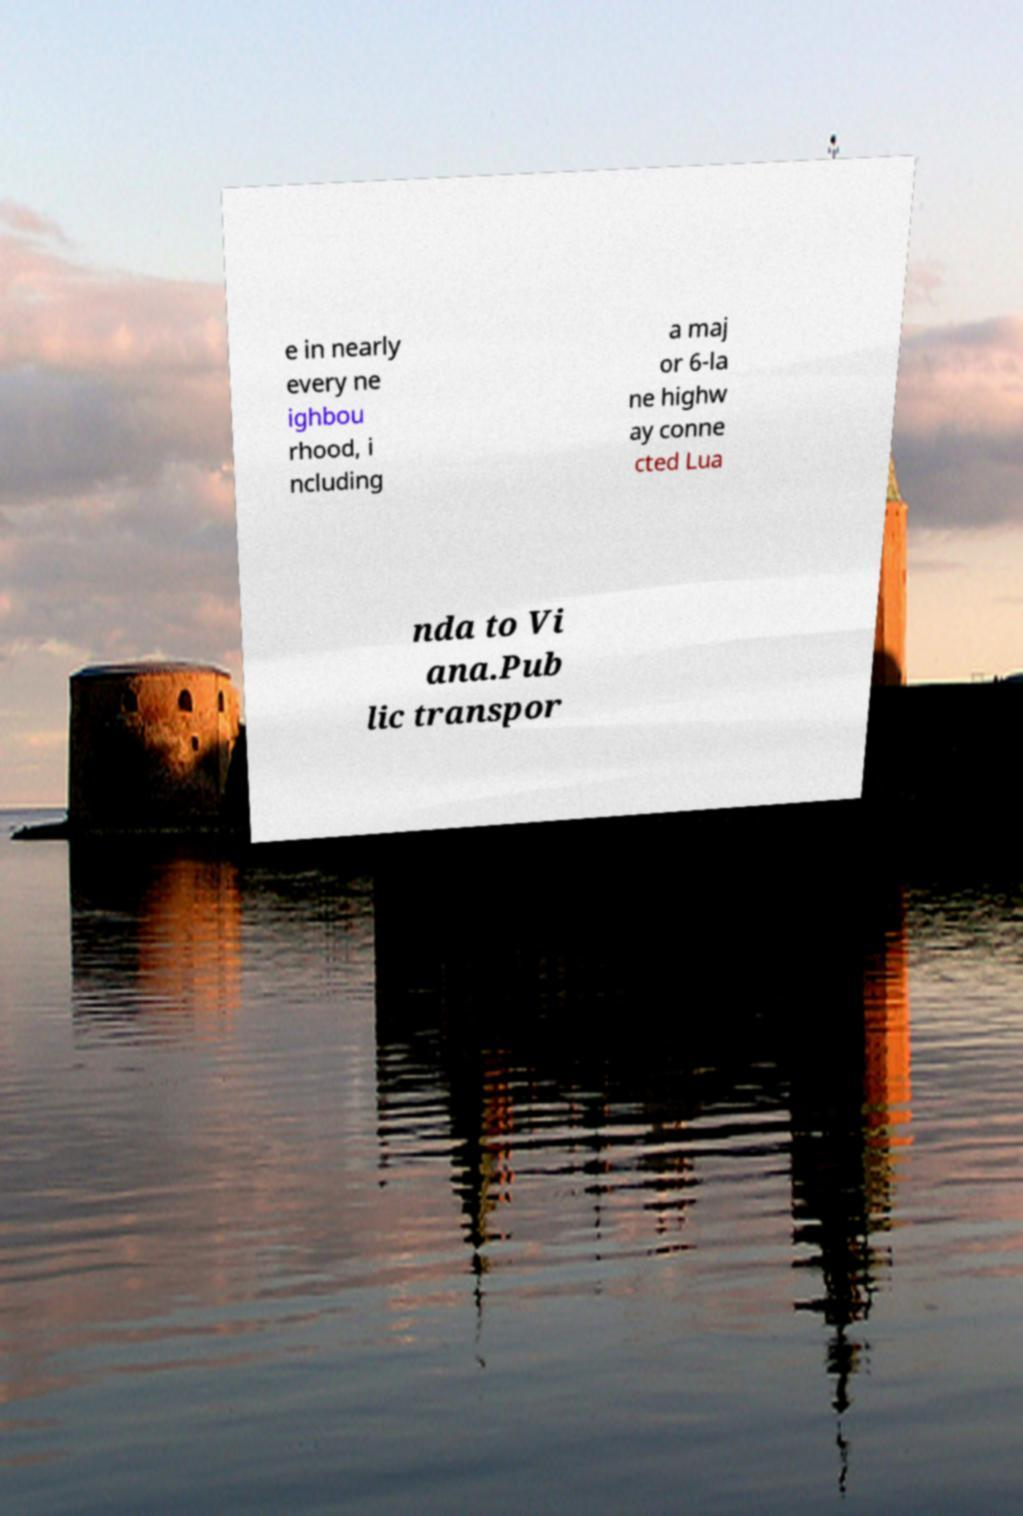Can you read and provide the text displayed in the image?This photo seems to have some interesting text. Can you extract and type it out for me? e in nearly every ne ighbou rhood, i ncluding a maj or 6-la ne highw ay conne cted Lua nda to Vi ana.Pub lic transpor 